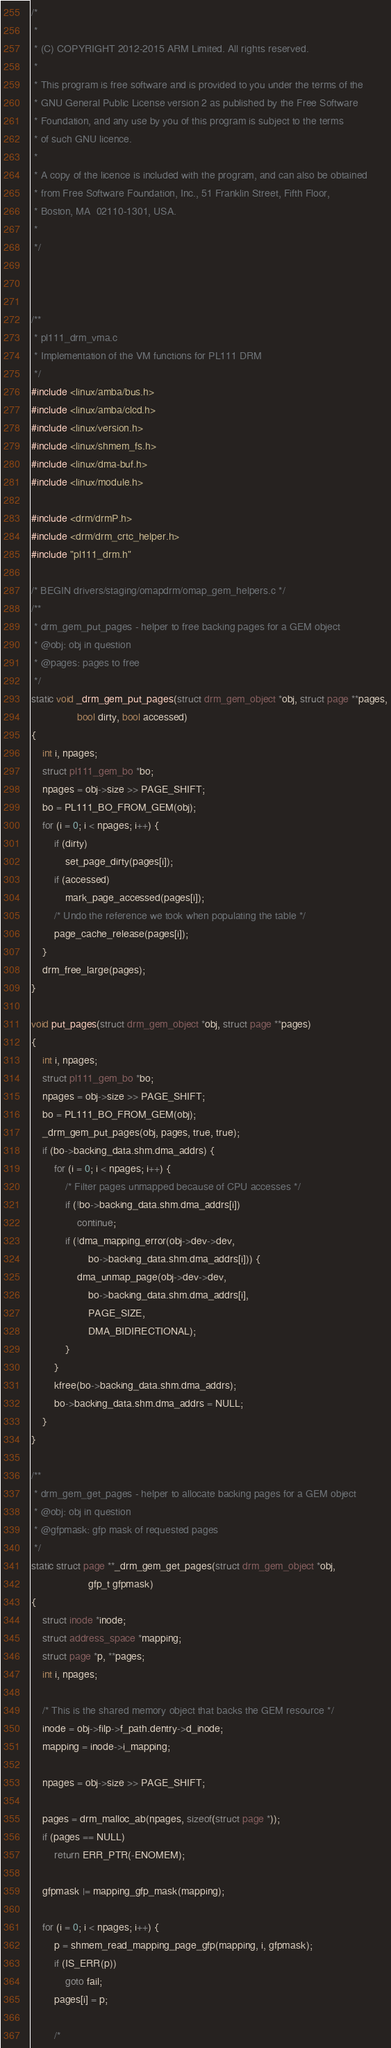Convert code to text. <code><loc_0><loc_0><loc_500><loc_500><_C_>/*
 *
 * (C) COPYRIGHT 2012-2015 ARM Limited. All rights reserved.
 *
 * This program is free software and is provided to you under the terms of the
 * GNU General Public License version 2 as published by the Free Software
 * Foundation, and any use by you of this program is subject to the terms
 * of such GNU licence.
 *
 * A copy of the licence is included with the program, and can also be obtained
 * from Free Software Foundation, Inc., 51 Franklin Street, Fifth Floor,
 * Boston, MA  02110-1301, USA.
 *
 */



/**
 * pl111_drm_vma.c
 * Implementation of the VM functions for PL111 DRM
 */
#include <linux/amba/bus.h>
#include <linux/amba/clcd.h>
#include <linux/version.h>
#include <linux/shmem_fs.h>
#include <linux/dma-buf.h>
#include <linux/module.h>

#include <drm/drmP.h>
#include <drm/drm_crtc_helper.h>
#include "pl111_drm.h"

/* BEGIN drivers/staging/omapdrm/omap_gem_helpers.c */
/**
 * drm_gem_put_pages - helper to free backing pages for a GEM object
 * @obj: obj in question
 * @pages: pages to free
 */
static void _drm_gem_put_pages(struct drm_gem_object *obj, struct page **pages,
				bool dirty, bool accessed)
{
	int i, npages;
	struct pl111_gem_bo *bo;
	npages = obj->size >> PAGE_SHIFT;
	bo = PL111_BO_FROM_GEM(obj);
	for (i = 0; i < npages; i++) {
		if (dirty)
			set_page_dirty(pages[i]);
		if (accessed)
			mark_page_accessed(pages[i]);
		/* Undo the reference we took when populating the table */
		page_cache_release(pages[i]);
	}
	drm_free_large(pages);
}

void put_pages(struct drm_gem_object *obj, struct page **pages)
{
	int i, npages;
	struct pl111_gem_bo *bo;
	npages = obj->size >> PAGE_SHIFT;
	bo = PL111_BO_FROM_GEM(obj);
	_drm_gem_put_pages(obj, pages, true, true);
	if (bo->backing_data.shm.dma_addrs) {
		for (i = 0; i < npages; i++) {
			/* Filter pages unmapped because of CPU accesses */
			if (!bo->backing_data.shm.dma_addrs[i])
				continue;
			if (!dma_mapping_error(obj->dev->dev,
					bo->backing_data.shm.dma_addrs[i])) {
				dma_unmap_page(obj->dev->dev,
					bo->backing_data.shm.dma_addrs[i],
					PAGE_SIZE,
					DMA_BIDIRECTIONAL);
			}
		}
		kfree(bo->backing_data.shm.dma_addrs);
		bo->backing_data.shm.dma_addrs = NULL;
	}
}

/**
 * drm_gem_get_pages - helper to allocate backing pages for a GEM object
 * @obj: obj in question
 * @gfpmask: gfp mask of requested pages
 */
static struct page **_drm_gem_get_pages(struct drm_gem_object *obj,
					gfp_t gfpmask)
{
	struct inode *inode;
	struct address_space *mapping;
	struct page *p, **pages;
	int i, npages;

	/* This is the shared memory object that backs the GEM resource */
	inode = obj->filp->f_path.dentry->d_inode;
	mapping = inode->i_mapping;

	npages = obj->size >> PAGE_SHIFT;

	pages = drm_malloc_ab(npages, sizeof(struct page *));
	if (pages == NULL)
		return ERR_PTR(-ENOMEM);

	gfpmask |= mapping_gfp_mask(mapping);

	for (i = 0; i < npages; i++) {
		p = shmem_read_mapping_page_gfp(mapping, i, gfpmask);
		if (IS_ERR(p))
			goto fail;
		pages[i] = p;

		/*</code> 